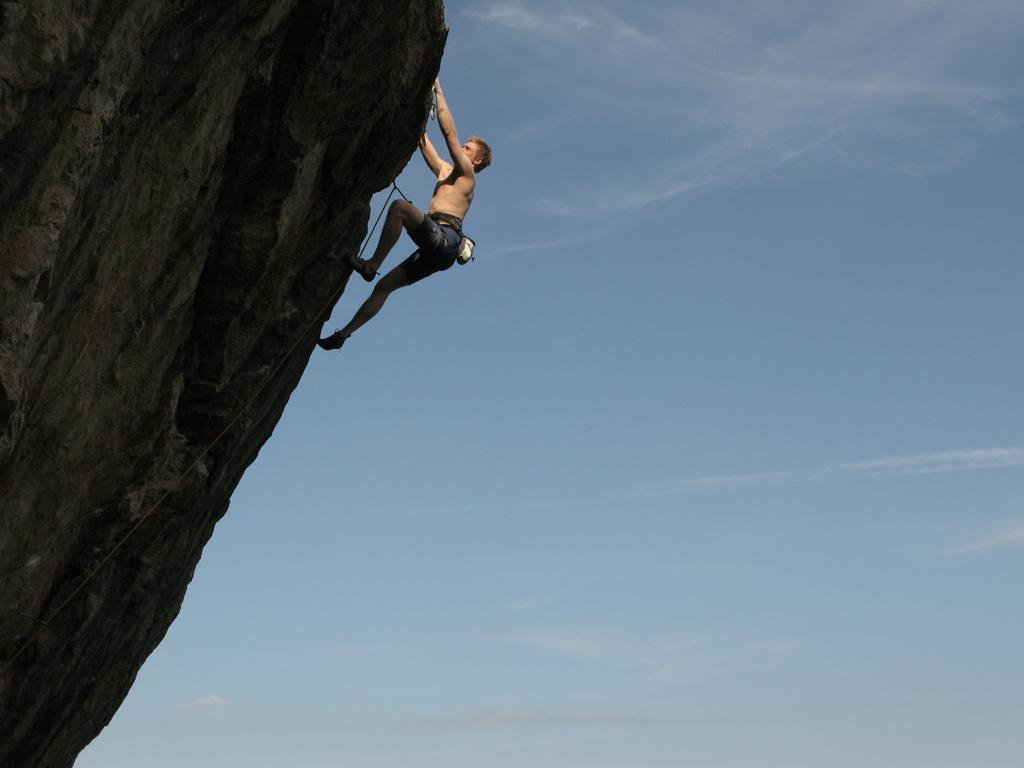What can be seen in the background of the image? The sky is visible in the image. What is located on the left side of the image? There is a mountain on the left side of the image. What is the man in the image doing? A man is climbing the mountain. What tool is being used by the man in the image? There is a rope in the image, which the man might be using for climbing. Can you tell me how many snails are running on the mountain in the image? There are no snails present in the image, and therefore no such activity can be observed. 